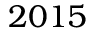<formula> <loc_0><loc_0><loc_500><loc_500>2 0 1 5</formula> 